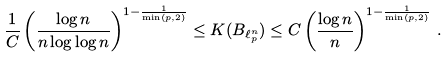Convert formula to latex. <formula><loc_0><loc_0><loc_500><loc_500>\frac { 1 } { C } \left ( \frac { \log n } { n \log \log n } \right ) ^ { 1 - \frac { 1 } { \min ( p , 2 ) } } \leq K ( B _ { \ell ^ { n } _ { p } } ) \leq C \left ( \frac { \log n } { n } \right ) ^ { 1 - \frac { 1 } { \min ( p , 2 ) } } \, .</formula> 